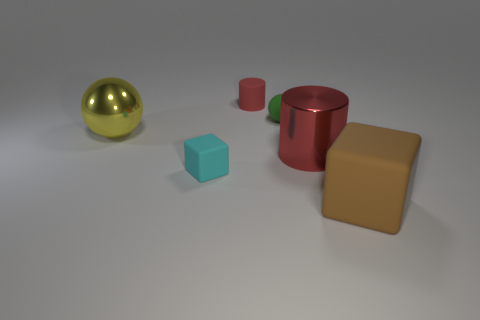How many tiny red objects have the same shape as the yellow object? 0 